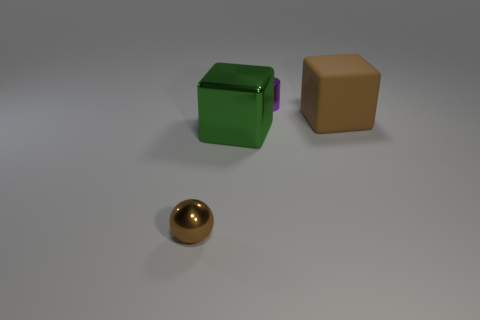Is there anything else that is the same material as the green object?
Provide a succinct answer. Yes. Is there a cube?
Your answer should be very brief. Yes. Does the large rubber block have the same color as the small thing in front of the big brown cube?
Keep it short and to the point. Yes. There is a brown object that is behind the brown object that is on the left side of the large brown matte thing that is on the right side of the small brown ball; what is its size?
Make the answer very short. Large. What number of big matte objects have the same color as the metal sphere?
Provide a short and direct response. 1. How many things are either brown things or brown things on the left side of the green metal thing?
Your answer should be compact. 2. What is the color of the metal cube?
Ensure brevity in your answer.  Green. What is the color of the large block that is in front of the large brown block?
Make the answer very short. Green. There is a brown thing that is on the left side of the large brown thing; how many tiny purple objects are right of it?
Keep it short and to the point. 1. Does the brown ball have the same size as the brown object that is behind the brown ball?
Your response must be concise. No. 